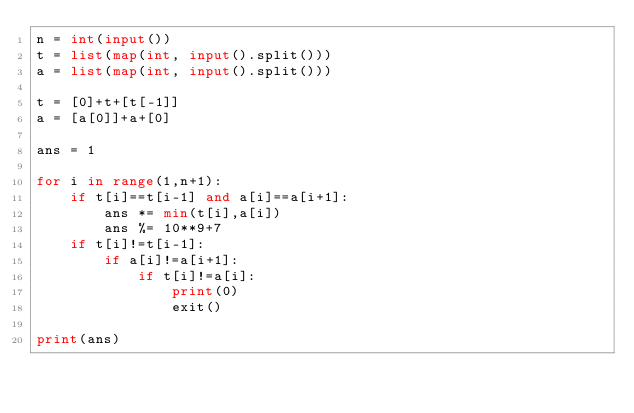<code> <loc_0><loc_0><loc_500><loc_500><_Python_>n = int(input())
t = list(map(int, input().split()))
a = list(map(int, input().split()))

t = [0]+t+[t[-1]]
a = [a[0]]+a+[0]

ans = 1

for i in range(1,n+1):
    if t[i]==t[i-1] and a[i]==a[i+1]:
        ans *= min(t[i],a[i])
        ans %= 10**9+7
    if t[i]!=t[i-1]:
        if a[i]!=a[i+1]:
            if t[i]!=a[i]:
                print(0)
                exit()

print(ans)</code> 